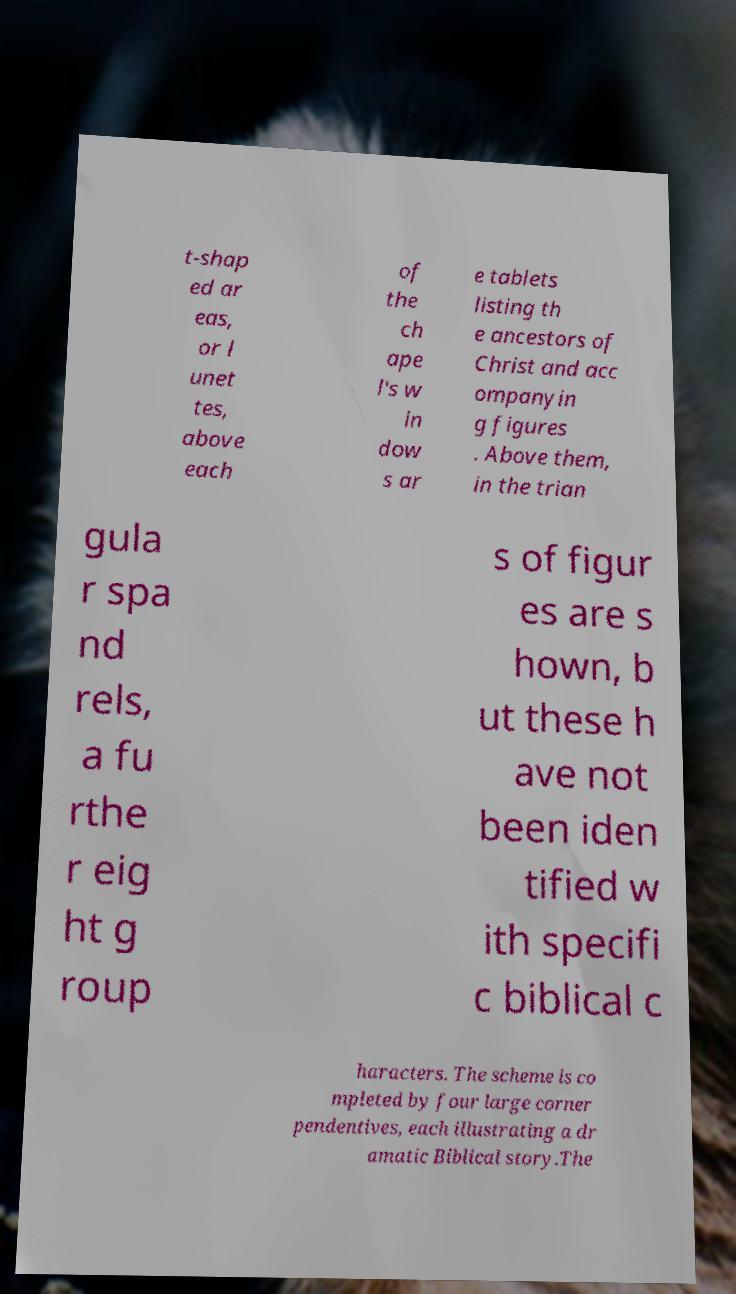I need the written content from this picture converted into text. Can you do that? t-shap ed ar eas, or l unet tes, above each of the ch ape l's w in dow s ar e tablets listing th e ancestors of Christ and acc ompanyin g figures . Above them, in the trian gula r spa nd rels, a fu rthe r eig ht g roup s of figur es are s hown, b ut these h ave not been iden tified w ith specifi c biblical c haracters. The scheme is co mpleted by four large corner pendentives, each illustrating a dr amatic Biblical story.The 